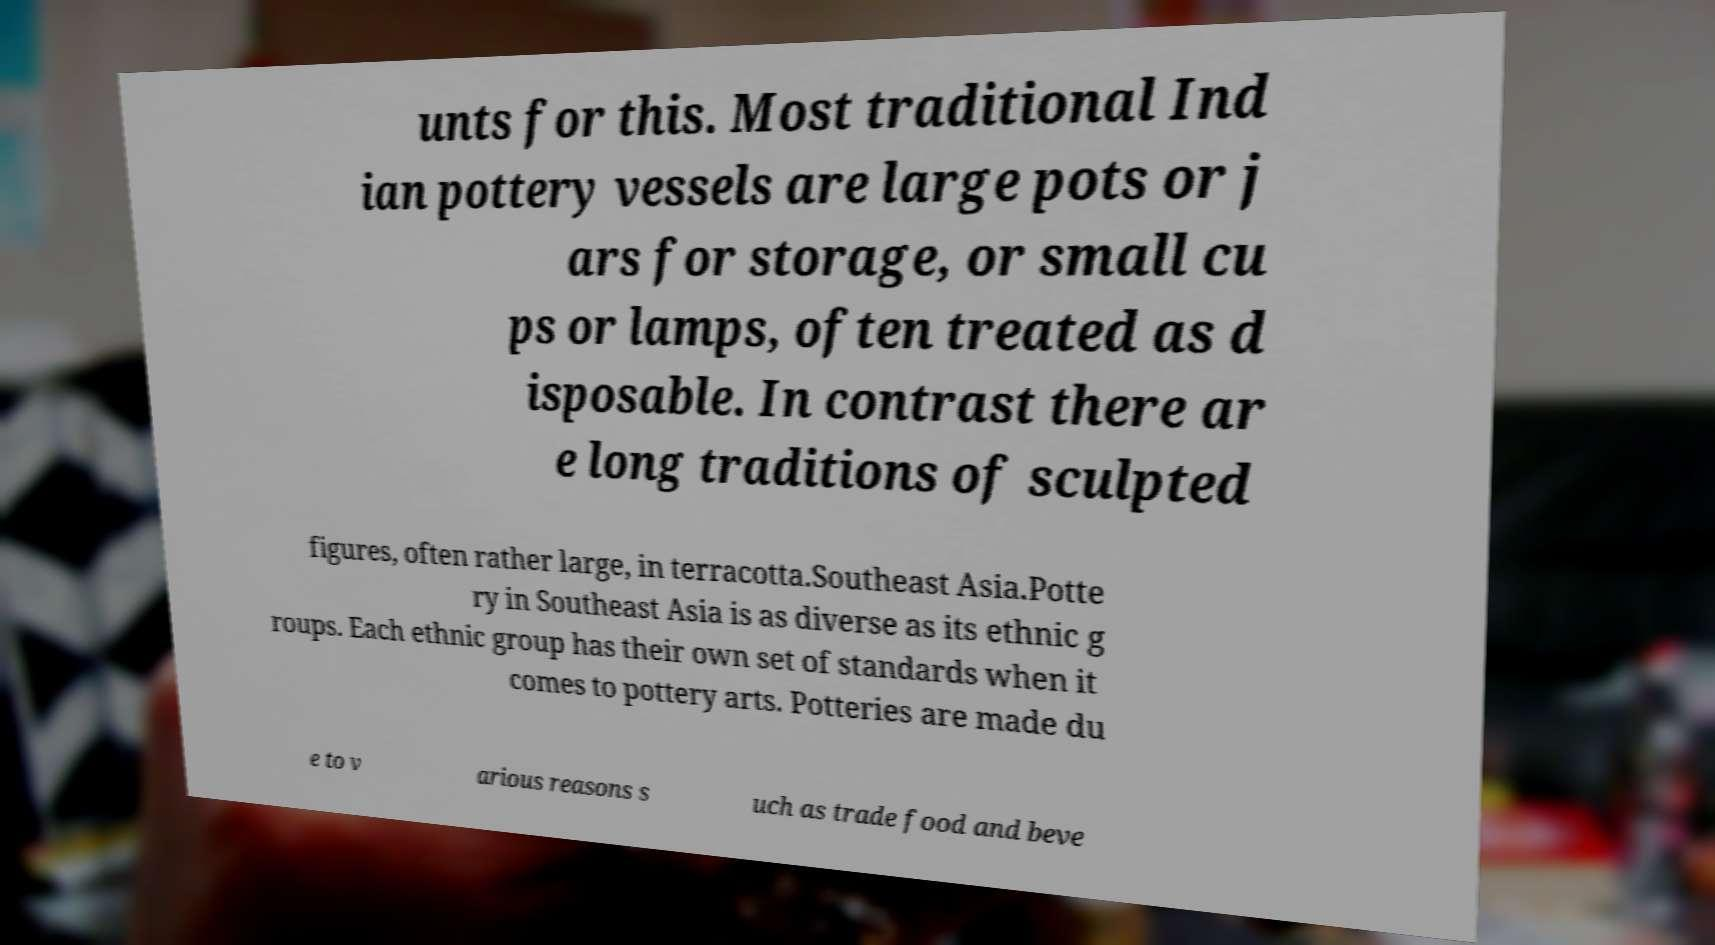Please read and relay the text visible in this image. What does it say? unts for this. Most traditional Ind ian pottery vessels are large pots or j ars for storage, or small cu ps or lamps, often treated as d isposable. In contrast there ar e long traditions of sculpted figures, often rather large, in terracotta.Southeast Asia.Potte ry in Southeast Asia is as diverse as its ethnic g roups. Each ethnic group has their own set of standards when it comes to pottery arts. Potteries are made du e to v arious reasons s uch as trade food and beve 